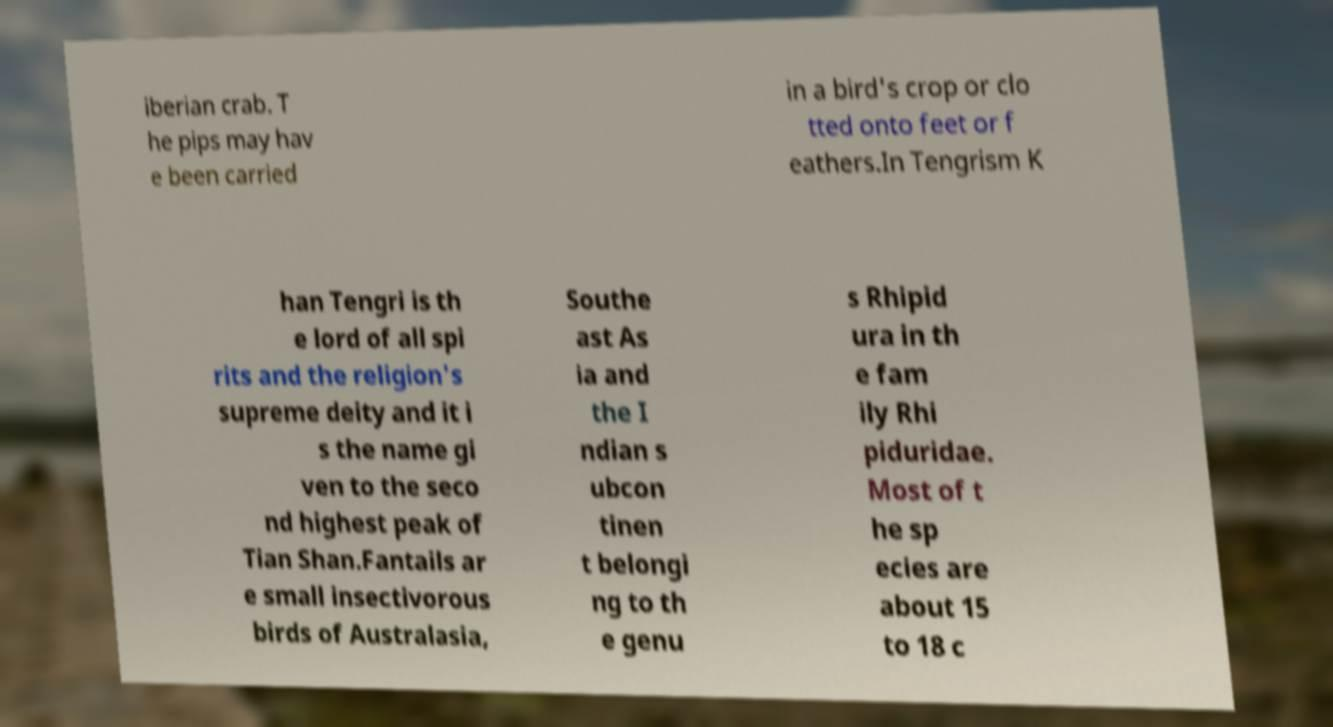Please identify and transcribe the text found in this image. iberian crab. T he pips may hav e been carried in a bird's crop or clo tted onto feet or f eathers.In Tengrism K han Tengri is th e lord of all spi rits and the religion's supreme deity and it i s the name gi ven to the seco nd highest peak of Tian Shan.Fantails ar e small insectivorous birds of Australasia, Southe ast As ia and the I ndian s ubcon tinen t belongi ng to th e genu s Rhipid ura in th e fam ily Rhi piduridae. Most of t he sp ecies are about 15 to 18 c 